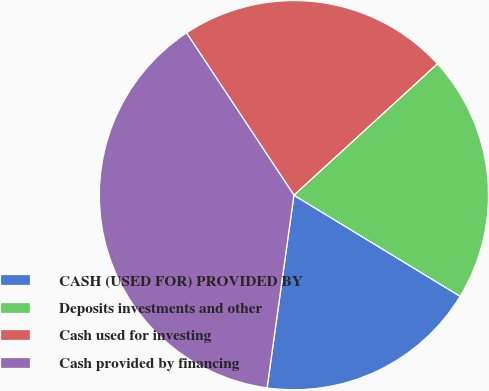Convert chart. <chart><loc_0><loc_0><loc_500><loc_500><pie_chart><fcel>CASH (USED FOR) PROVIDED BY<fcel>Deposits investments and other<fcel>Cash used for investing<fcel>Cash provided by financing<nl><fcel>18.5%<fcel>20.5%<fcel>22.5%<fcel>38.49%<nl></chart> 